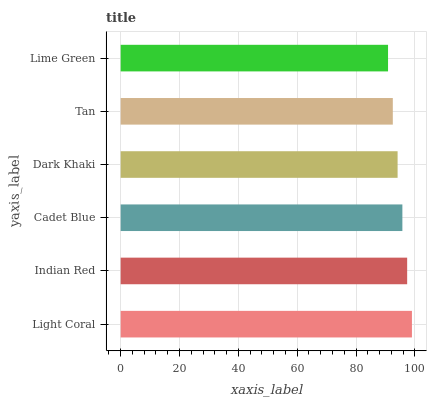Is Lime Green the minimum?
Answer yes or no. Yes. Is Light Coral the maximum?
Answer yes or no. Yes. Is Indian Red the minimum?
Answer yes or no. No. Is Indian Red the maximum?
Answer yes or no. No. Is Light Coral greater than Indian Red?
Answer yes or no. Yes. Is Indian Red less than Light Coral?
Answer yes or no. Yes. Is Indian Red greater than Light Coral?
Answer yes or no. No. Is Light Coral less than Indian Red?
Answer yes or no. No. Is Cadet Blue the high median?
Answer yes or no. Yes. Is Dark Khaki the low median?
Answer yes or no. Yes. Is Light Coral the high median?
Answer yes or no. No. Is Light Coral the low median?
Answer yes or no. No. 